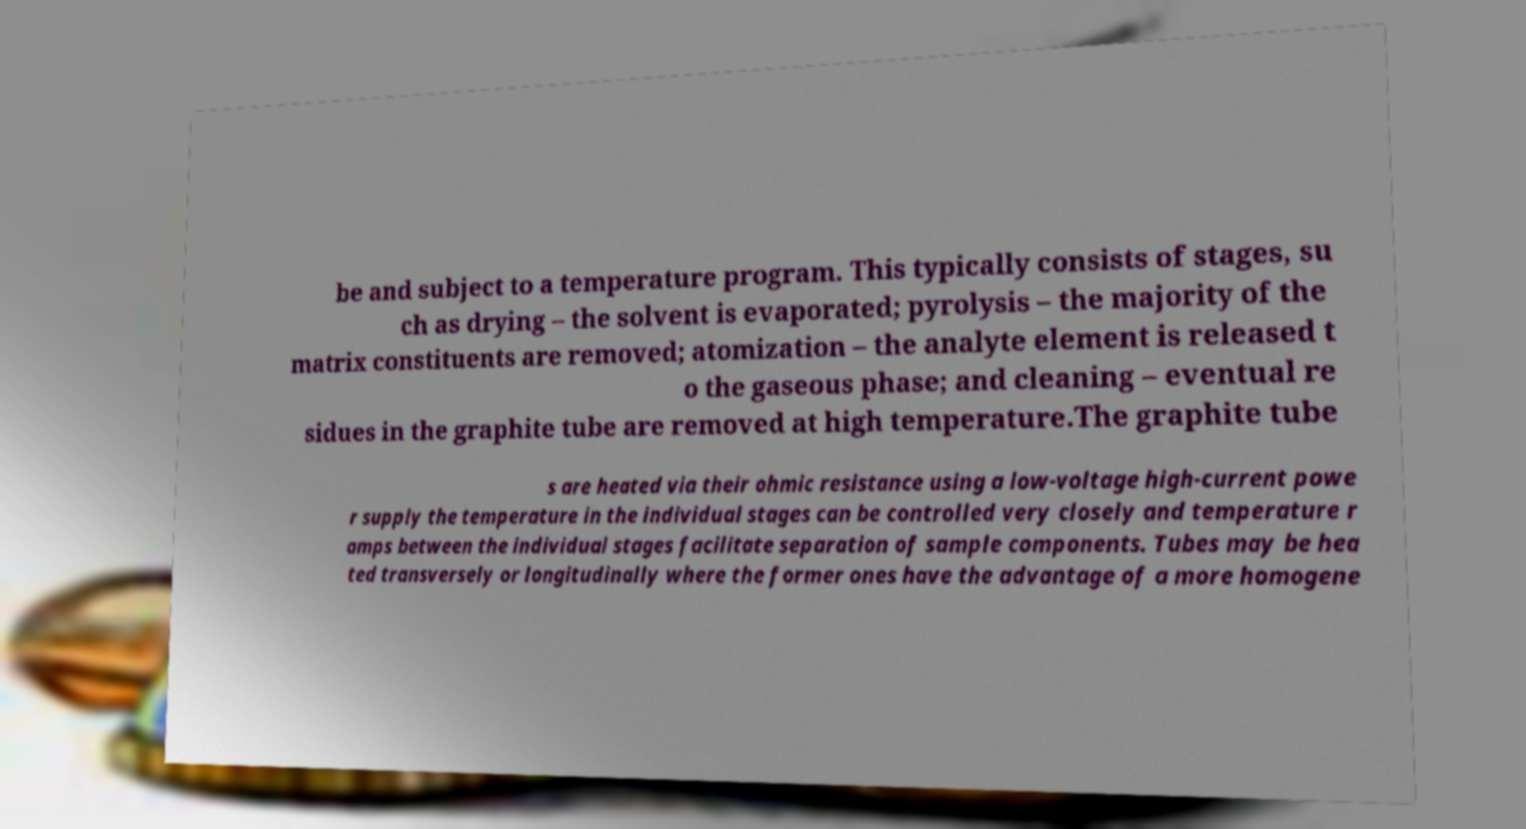What messages or text are displayed in this image? I need them in a readable, typed format. be and subject to a temperature program. This typically consists of stages, su ch as drying – the solvent is evaporated; pyrolysis – the majority of the matrix constituents are removed; atomization – the analyte element is released t o the gaseous phase; and cleaning – eventual re sidues in the graphite tube are removed at high temperature.The graphite tube s are heated via their ohmic resistance using a low-voltage high-current powe r supply the temperature in the individual stages can be controlled very closely and temperature r amps between the individual stages facilitate separation of sample components. Tubes may be hea ted transversely or longitudinally where the former ones have the advantage of a more homogene 